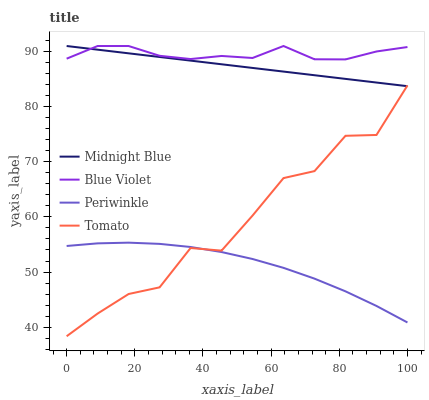Does Periwinkle have the minimum area under the curve?
Answer yes or no. Yes. Does Blue Violet have the maximum area under the curve?
Answer yes or no. Yes. Does Midnight Blue have the minimum area under the curve?
Answer yes or no. No. Does Midnight Blue have the maximum area under the curve?
Answer yes or no. No. Is Midnight Blue the smoothest?
Answer yes or no. Yes. Is Tomato the roughest?
Answer yes or no. Yes. Is Periwinkle the smoothest?
Answer yes or no. No. Is Periwinkle the roughest?
Answer yes or no. No. Does Tomato have the lowest value?
Answer yes or no. Yes. Does Periwinkle have the lowest value?
Answer yes or no. No. Does Blue Violet have the highest value?
Answer yes or no. Yes. Does Periwinkle have the highest value?
Answer yes or no. No. Is Tomato less than Blue Violet?
Answer yes or no. Yes. Is Midnight Blue greater than Periwinkle?
Answer yes or no. Yes. Does Midnight Blue intersect Blue Violet?
Answer yes or no. Yes. Is Midnight Blue less than Blue Violet?
Answer yes or no. No. Is Midnight Blue greater than Blue Violet?
Answer yes or no. No. Does Tomato intersect Blue Violet?
Answer yes or no. No. 